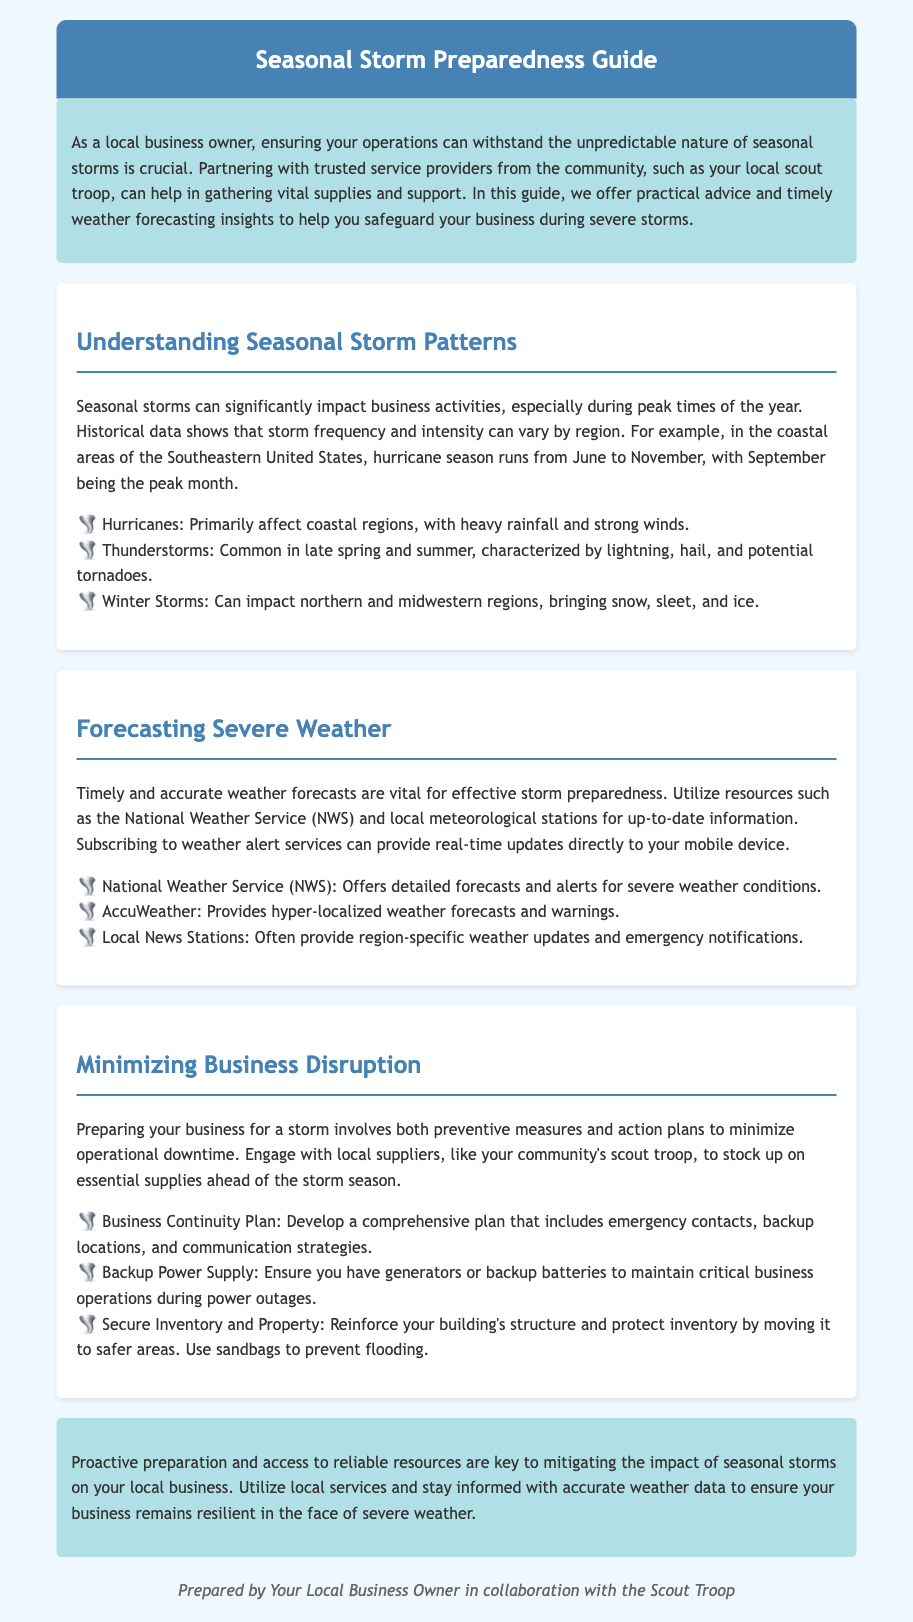What is the title of the document? The title is found in the header of the document.
Answer: Seasonal Storm Preparedness Guide What is the main purpose of the guide? The introduction provides the main purpose of the guide.
Answer: Storm preparedness Which months encompass hurricane season in coastal areas of the Southeastern United States? The document specifies when hurricane season occurs.
Answer: June to November What should a business continuity plan include? The section on minimizing business disruption lists components of a business continuity plan.
Answer: Emergency contacts, backup locations, and communication strategies What service provides hyper-localized weather forecasts? Forecasting severe weather section mentions specific services.
Answer: AccuWeather What is a significant characteristic of thunderstorms? The document outlines characteristics of thunderstorms in the section about storm patterns.
Answer: Lightning, hail, and potential tornadoes How can local suppliers help during storm preparedness? The guide mentions engaging with local suppliers to minimize operational downtime.
Answer: Stock up on essential supplies What type of power supply should businesses ensure? The section on minimizing business disruption suggests measures to maintain operations.
Answer: Backup Power Supply What can be used to prevent flooding? The document provides recommendations for securing property during storms.
Answer: Sandbags 